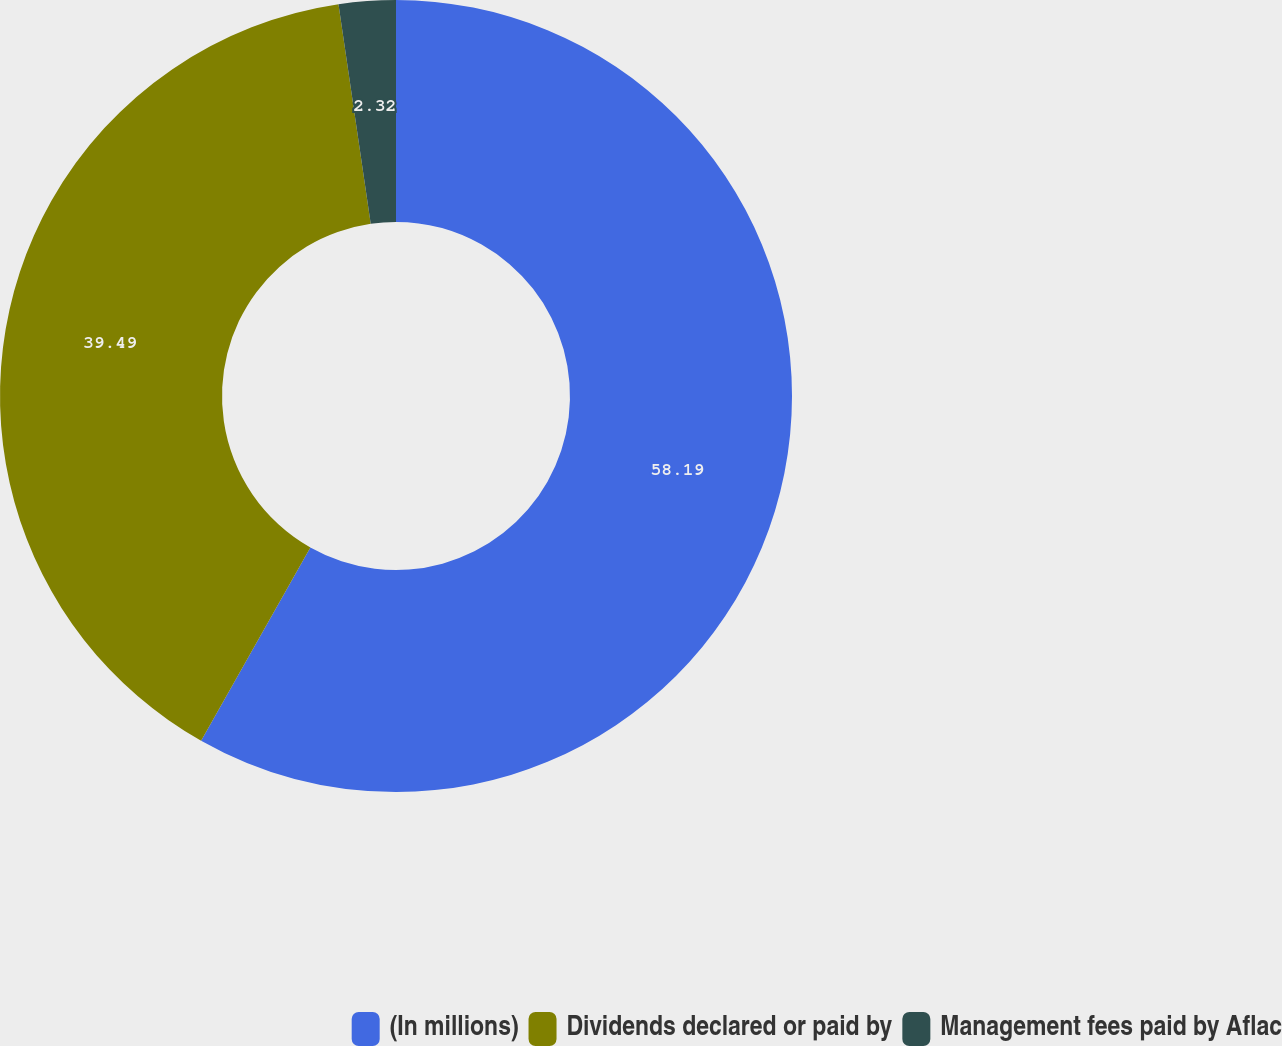<chart> <loc_0><loc_0><loc_500><loc_500><pie_chart><fcel>(In millions)<fcel>Dividends declared or paid by<fcel>Management fees paid by Aflac<nl><fcel>58.19%<fcel>39.49%<fcel>2.32%<nl></chart> 